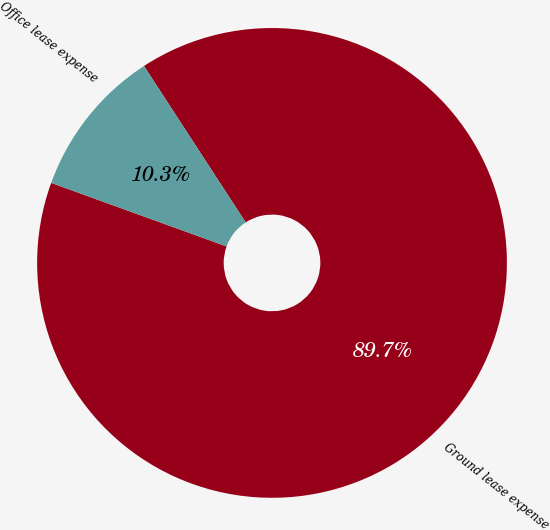Convert chart. <chart><loc_0><loc_0><loc_500><loc_500><pie_chart><fcel>Ground lease expense<fcel>Office lease expense<nl><fcel>89.71%<fcel>10.29%<nl></chart> 